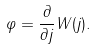Convert formula to latex. <formula><loc_0><loc_0><loc_500><loc_500>\varphi = \frac { \partial } { \partial j } W ( j ) .</formula> 